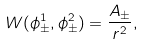<formula> <loc_0><loc_0><loc_500><loc_500>W ( \phi ^ { 1 } _ { \pm } , \phi ^ { 2 } _ { \pm } ) = \frac { A _ { \pm } } { r ^ { 2 } } ,</formula> 